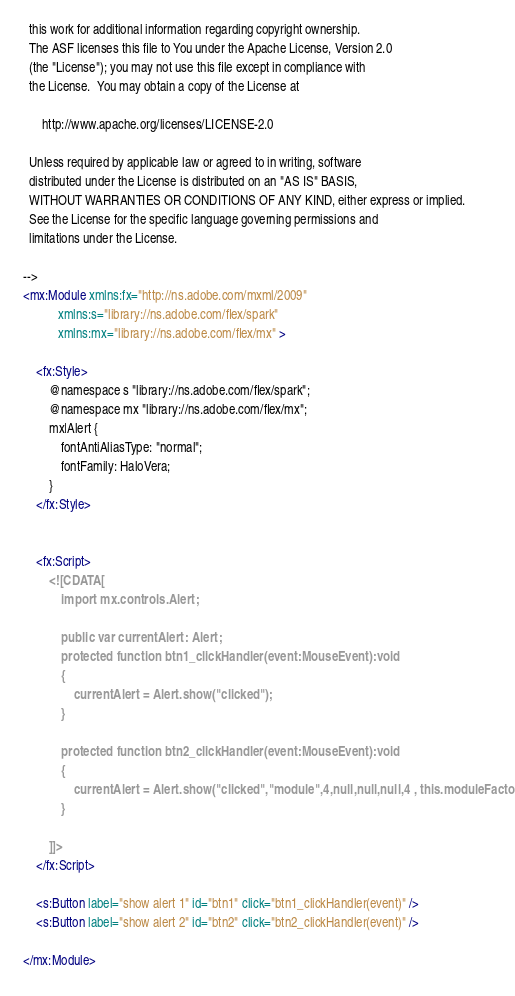<code> <loc_0><loc_0><loc_500><loc_500><_XML_>  this work for additional information regarding copyright ownership.
  The ASF licenses this file to You under the Apache License, Version 2.0
  (the "License"); you may not use this file except in compliance with
  the License.  You may obtain a copy of the License at

      http://www.apache.org/licenses/LICENSE-2.0

  Unless required by applicable law or agreed to in writing, software
  distributed under the License is distributed on an "AS IS" BASIS,
  WITHOUT WARRANTIES OR CONDITIONS OF ANY KIND, either express or implied.
  See the License for the specific language governing permissions and
  limitations under the License.

-->
<mx:Module xmlns:fx="http://ns.adobe.com/mxml/2009" 
		   xmlns:s="library://ns.adobe.com/flex/spark" 
		   xmlns:mx="library://ns.adobe.com/flex/mx" >
	
	<fx:Style>
		@namespace s "library://ns.adobe.com/flex/spark";
		@namespace mx "library://ns.adobe.com/flex/mx";
		mx|Alert {
			fontAntiAliasType: "normal";
			fontFamily: HaloVera;
		}
	</fx:Style>
	

	<fx:Script>
		<![CDATA[
			import mx.controls.Alert;
			
			public var currentAlert: Alert;
			protected function btn1_clickHandler(event:MouseEvent):void
			{
				currentAlert = Alert.show("clicked");
			}

			protected function btn2_clickHandler(event:MouseEvent):void
			{
				currentAlert = Alert.show("clicked","module",4,null,null,null,4 , this.moduleFactory);
			}

		]]>
	</fx:Script>

	<s:Button label="show alert 1" id="btn1" click="btn1_clickHandler(event)" />
	<s:Button label="show alert 2" id="btn2" click="btn2_clickHandler(event)" />
	
</mx:Module></code> 